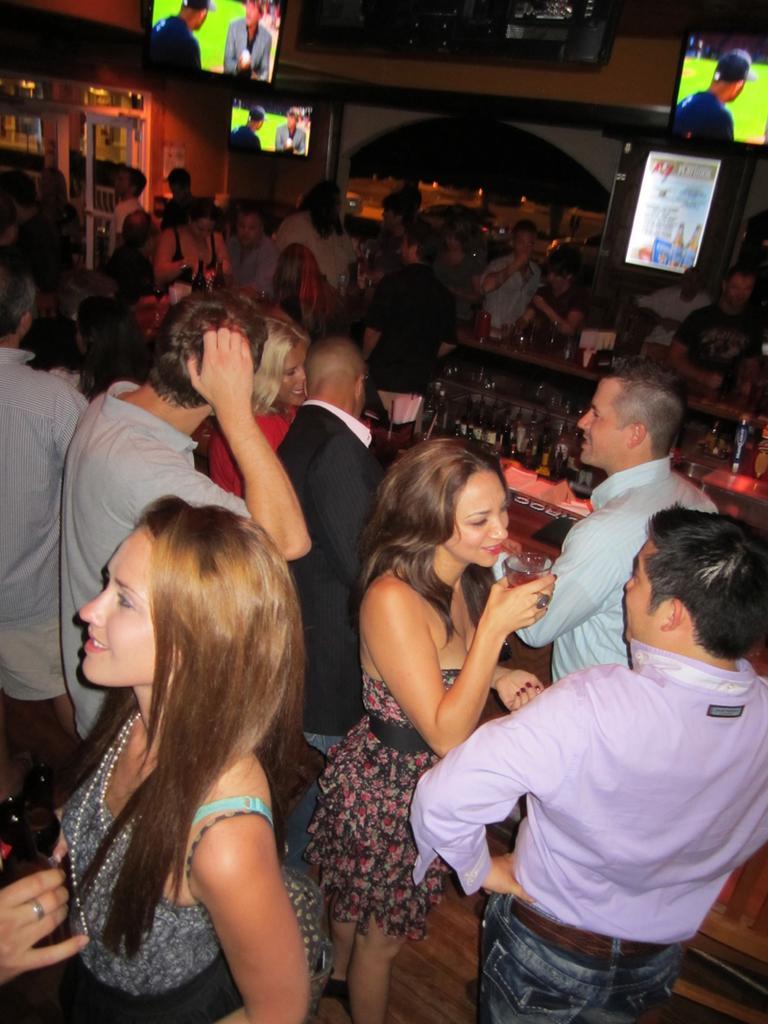How would you summarize this image in a sentence or two? In this image on the right there is a man, he wears a shirt, trouser, in front of him there is a woman, she wears a dress, she is holding a glass. On the left there is a woman, she wears a dress, her hair is short and there is a man, he wears a dress. In the middle there are many people, tvs , screens, posters, drinks, tissues, wall. 